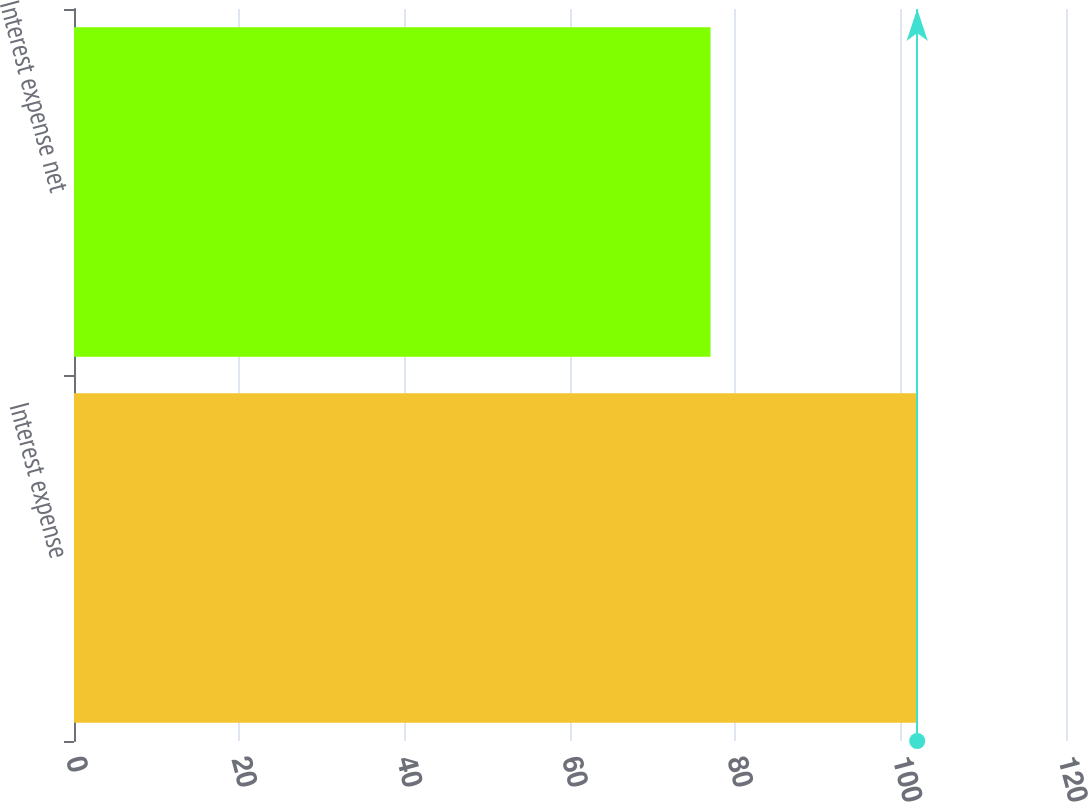<chart> <loc_0><loc_0><loc_500><loc_500><bar_chart><fcel>Interest expense<fcel>Interest expense net<nl><fcel>102<fcel>77<nl></chart> 